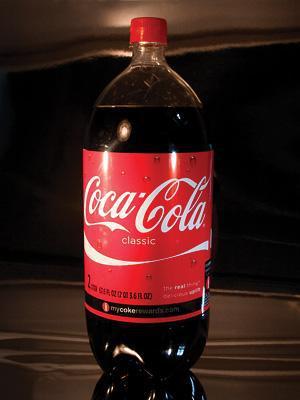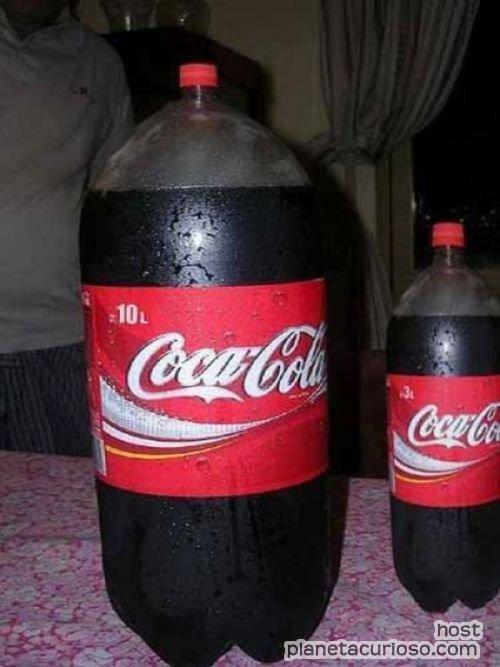The first image is the image on the left, the second image is the image on the right. Examine the images to the left and right. Is the description "The left image features one full bottle of cola with a red wrapper standing upright, and the right image contains two full bottles of cola with red wrappers positioned side-by-side." accurate? Answer yes or no. Yes. The first image is the image on the left, the second image is the image on the right. Considering the images on both sides, is "There are exactly three bottles of soda." valid? Answer yes or no. Yes. 